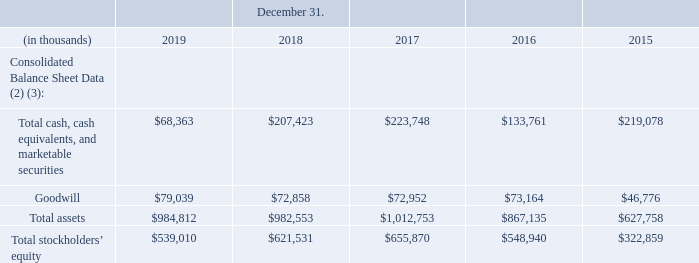ITEM 6. SELECTED FINANCIAL DATA
The selected financial data presented below has been derived from our audited consolidated financial statements. This data should be read in conjunction with “Item 7. Management’s Discussion and Analysis of Financial Condition and Results of Operations” and “Item 8. Financial Statements and Supplementary Data” of this Annual Report.
(2) We retrospectively adopted ASU 2014-09, “Revenue from Contracts with Customers (Topic 606)” in 2018. As a result, we have adjusted balances for 2017 and 2016. We have not adjusted 2015 for ASU 2014-09.
(3) On January 1, 2019, we adopted Accounting Standards Codification 842 “Leases” (“ASC 842”) using the modified retrospective method, reflecting any cumulative effect as an adjustment to equity. Results for reporting periods beginning on or after January 1, 2019 are presented under ASC 842, while prior period amounts were not adjusted and continue to be reported in accordance with the Company’s historical accounting under ASC 840 “Leases.”
What are the respective goodwill amounts in 2015 and 2016?
Answer scale should be: thousand. $46,776, $73,164. What are the respective goodwill amounts in 2016 and 2017?
Answer scale should be: thousand. $73,164, $72,952. What are the respective goodwill amounts in 2018 and 2019?
Answer scale should be: thousand. $72,858, $79,039. What is the average total cash, cash equivalents, and marketable securities in 2015 and 2016?
Answer scale should be: thousand. ($219,078 + $133,761)/2 
Answer: 176419.5. What is the percentage change in the company's goodwill between 2017 and 2018?
Answer scale should be: percent. (72,858 - 72,952)/72,952 
Answer: -0.13. What is the percentage change in the company's goodwill between 2018 and 2019?
Answer scale should be: percent. (79,039 - 72,858)/72,858 
Answer: 8.48. 